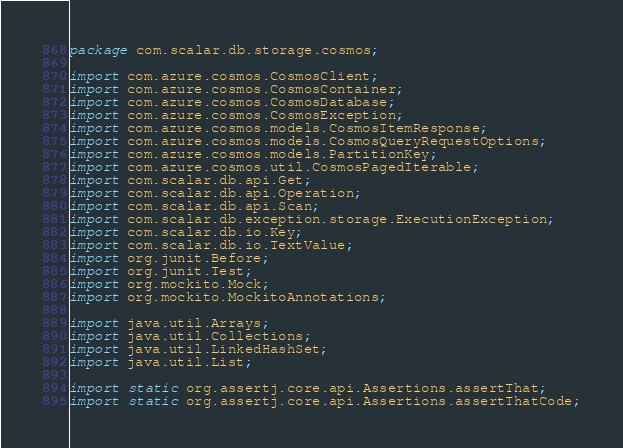Convert code to text. <code><loc_0><loc_0><loc_500><loc_500><_Java_>package com.scalar.db.storage.cosmos;

import com.azure.cosmos.CosmosClient;
import com.azure.cosmos.CosmosContainer;
import com.azure.cosmos.CosmosDatabase;
import com.azure.cosmos.CosmosException;
import com.azure.cosmos.models.CosmosItemResponse;
import com.azure.cosmos.models.CosmosQueryRequestOptions;
import com.azure.cosmos.models.PartitionKey;
import com.azure.cosmos.util.CosmosPagedIterable;
import com.scalar.db.api.Get;
import com.scalar.db.api.Operation;
import com.scalar.db.api.Scan;
import com.scalar.db.exception.storage.ExecutionException;
import com.scalar.db.io.Key;
import com.scalar.db.io.TextValue;
import org.junit.Before;
import org.junit.Test;
import org.mockito.Mock;
import org.mockito.MockitoAnnotations;

import java.util.Arrays;
import java.util.Collections;
import java.util.LinkedHashSet;
import java.util.List;

import static org.assertj.core.api.Assertions.assertThat;
import static org.assertj.core.api.Assertions.assertThatCode;</code> 